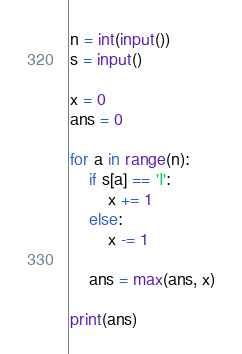Convert code to text. <code><loc_0><loc_0><loc_500><loc_500><_Python_>n = int(input())
s = input()

x = 0
ans = 0

for a in range(n):
    if s[a] == 'I':
        x += 1
    else:
        x -= 1

    ans = max(ans, x)

print(ans)
</code> 